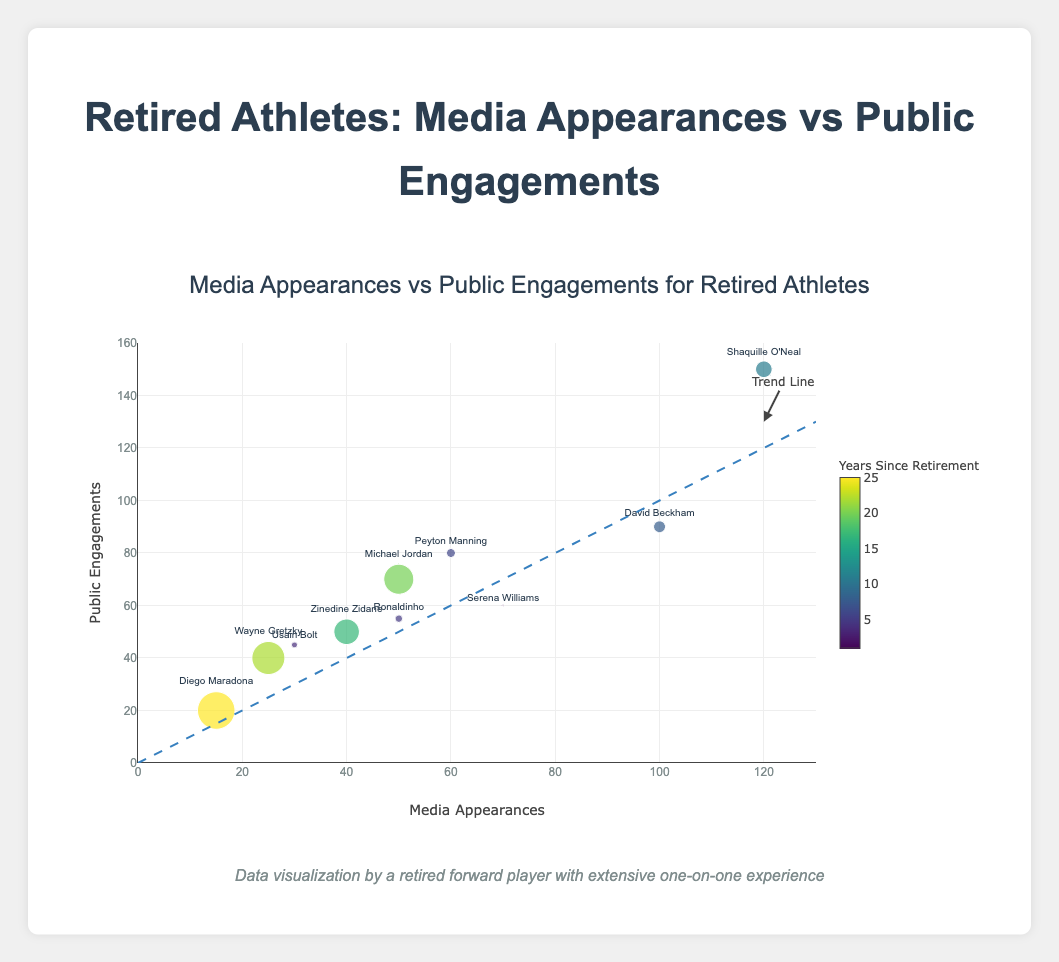How does the trend line help to interpret the data? The trend line, represented by a dashed line, shows the overall direction of the relationship between media appearances and public engagements. It helps to understand if there’s a positive, negative, or no correlation.
Answer: It shows a positive correlation Which athlete had the highest media appearances? To identify the athlete with the highest media appearances, find the data point with the highest x-coordinate.
Answer: Shaquille O'Neal Which athlete has the smallest marker size? What does it indicate? The smallest marker is the point with the smallest circle, indicating the least years since retirement.
Answer: Serena Williams (1 year) Who has more public engagements, Michael Jordan or Wayne Gretzky? Compare the y-coordinate values for Michael Jordan and Wayne Gretzky.
Answer: Michael Jordan (70 vs. 40) Which athlete is closest to the trend line but has retired for more than 15 years? Identify data points close to the trend line and check their markers; those with years since retirement greater than 15.
Answer: Zinedine Zidane Which athlete has the lowest public engagement but more than 50 media appearances? Look for a data point with y-coordinate at the lowest value but with x-coordinate greater than 50.
Answer: Diego Maradona What is the average number of public engagements for athletes with more than 100 media appearances? Athletes fitting the criteria: David Beckham (90) and Shaquille O'Neal (150). Average: (90 + 150) / 2 = 120.
Answer: 120 What does the color of the marker represent and how does its gradient affect interpretation? Color represents years since retirement; darker means more years. Gradient helps to visually group athletes by their retirement recency.
Answer: Years since retirement What are the titles of the axes and what range do they cover? The x-axis title is "Media Appearances" ranging from 0 to 130, and the y-axis title is "Public Engagements" ranging from 0 to 160.
Answer: Media Appearances: 0-130, Public Engagements: 0-160 Which athlete has both media appearances and public engagements above 100? Find the data point with both coordinates greater than 100.
Answer: Shaquille O'Neal 